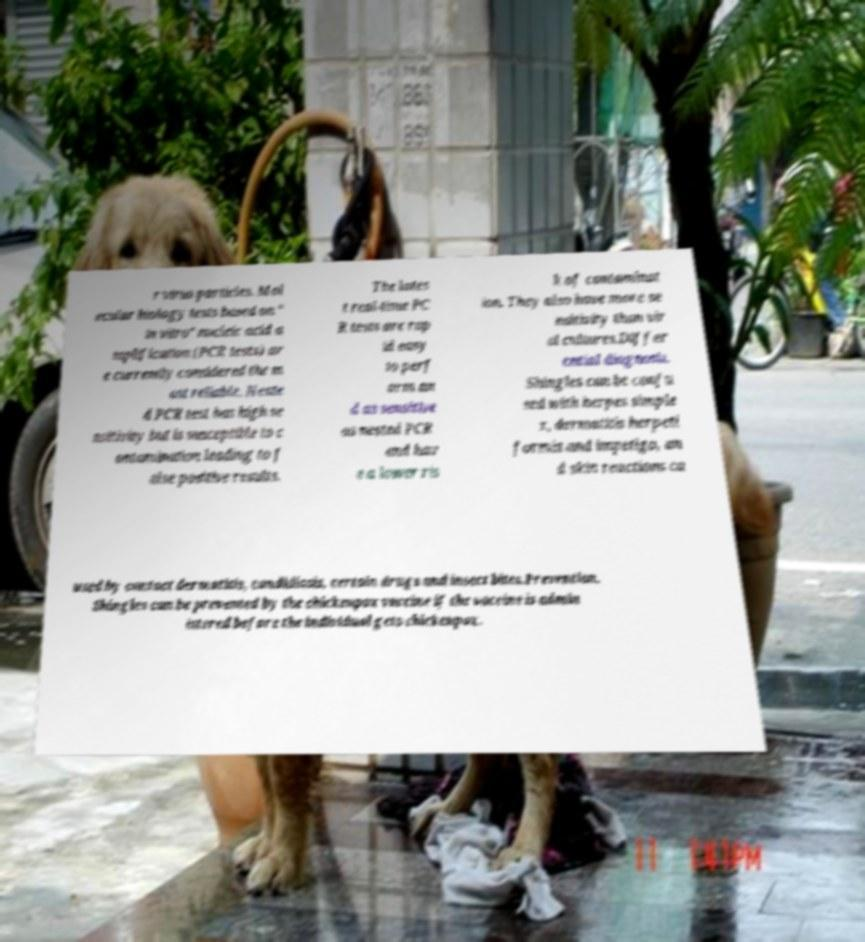I need the written content from this picture converted into text. Can you do that? r virus particles. Mol ecular biology tests based on " in vitro" nucleic acid a mplification (PCR tests) ar e currently considered the m ost reliable. Neste d PCR test has high se nsitivity but is susceptible to c ontamination leading to f alse positive results. The lates t real-time PC R tests are rap id easy to perf orm an d as sensitive as nested PCR and hav e a lower ris k of contaminat ion. They also have more se nsitivity than vir al cultures.Differ ential diagnosis. Shingles can be confu sed with herpes simple x, dermatitis herpeti formis and impetigo, an d skin reactions ca used by contact dermatitis, candidiasis, certain drugs and insect bites.Prevention. Shingles can be prevented by the chickenpox vaccine if the vaccine is admin istered before the individual gets chickenpox. 